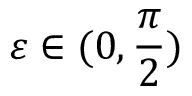<formula> <loc_0><loc_0><loc_500><loc_500>\varepsilon \in ( 0 , \frac { \pi } { 2 } )</formula> 